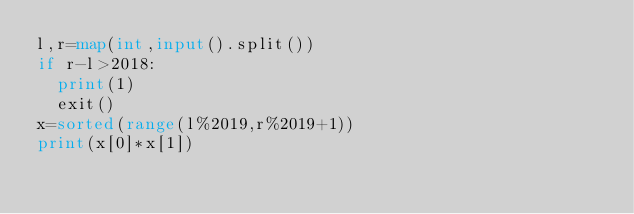<code> <loc_0><loc_0><loc_500><loc_500><_Python_>l,r=map(int,input().split())
if r-l>2018:
  print(1)
  exit()
x=sorted(range(l%2019,r%2019+1))
print(x[0]*x[1])</code> 